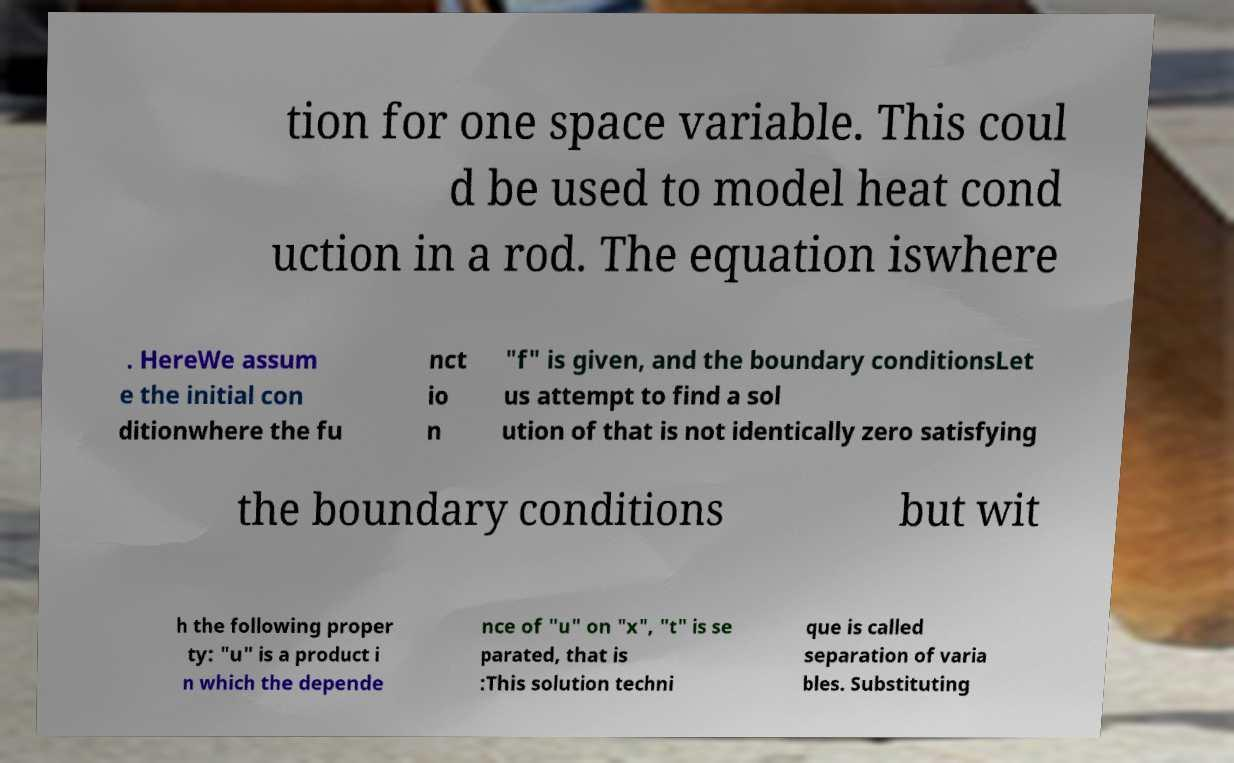Please read and relay the text visible in this image. What does it say? tion for one space variable. This coul d be used to model heat cond uction in a rod. The equation iswhere . HereWe assum e the initial con ditionwhere the fu nct io n "f" is given, and the boundary conditionsLet us attempt to find a sol ution of that is not identically zero satisfying the boundary conditions but wit h the following proper ty: "u" is a product i n which the depende nce of "u" on "x", "t" is se parated, that is :This solution techni que is called separation of varia bles. Substituting 